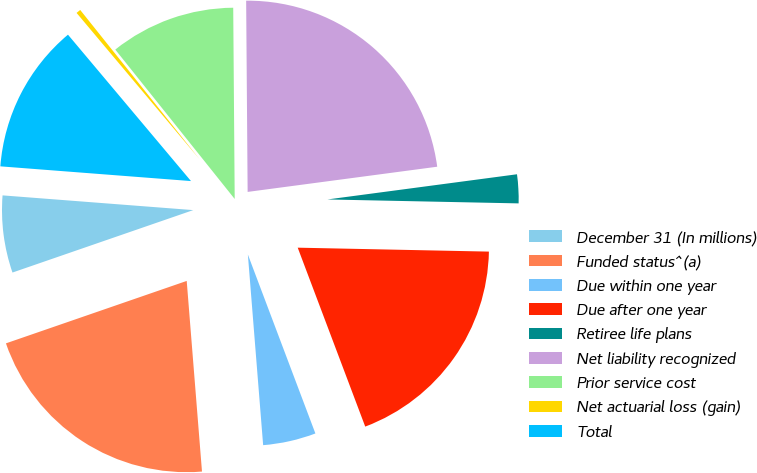Convert chart to OTSL. <chart><loc_0><loc_0><loc_500><loc_500><pie_chart><fcel>December 31 (In millions)<fcel>Funded status^(a)<fcel>Due within one year<fcel>Due after one year<fcel>Retiree life plans<fcel>Net liability recognized<fcel>Prior service cost<fcel>Net actuarial loss (gain)<fcel>Total<nl><fcel>6.52%<fcel>20.98%<fcel>4.47%<fcel>18.93%<fcel>2.43%<fcel>23.02%<fcel>10.61%<fcel>0.39%<fcel>12.65%<nl></chart> 